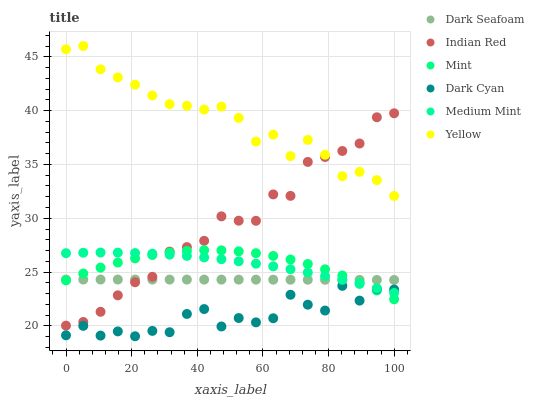Does Dark Cyan have the minimum area under the curve?
Answer yes or no. Yes. Does Yellow have the maximum area under the curve?
Answer yes or no. Yes. Does Dark Seafoam have the minimum area under the curve?
Answer yes or no. No. Does Dark Seafoam have the maximum area under the curve?
Answer yes or no. No. Is Dark Seafoam the smoothest?
Answer yes or no. Yes. Is Dark Cyan the roughest?
Answer yes or no. Yes. Is Yellow the smoothest?
Answer yes or no. No. Is Yellow the roughest?
Answer yes or no. No. Does Dark Cyan have the lowest value?
Answer yes or no. Yes. Does Dark Seafoam have the lowest value?
Answer yes or no. No. Does Yellow have the highest value?
Answer yes or no. Yes. Does Dark Seafoam have the highest value?
Answer yes or no. No. Is Dark Cyan less than Indian Red?
Answer yes or no. Yes. Is Yellow greater than Medium Mint?
Answer yes or no. Yes. Does Indian Red intersect Dark Seafoam?
Answer yes or no. Yes. Is Indian Red less than Dark Seafoam?
Answer yes or no. No. Is Indian Red greater than Dark Seafoam?
Answer yes or no. No. Does Dark Cyan intersect Indian Red?
Answer yes or no. No. 